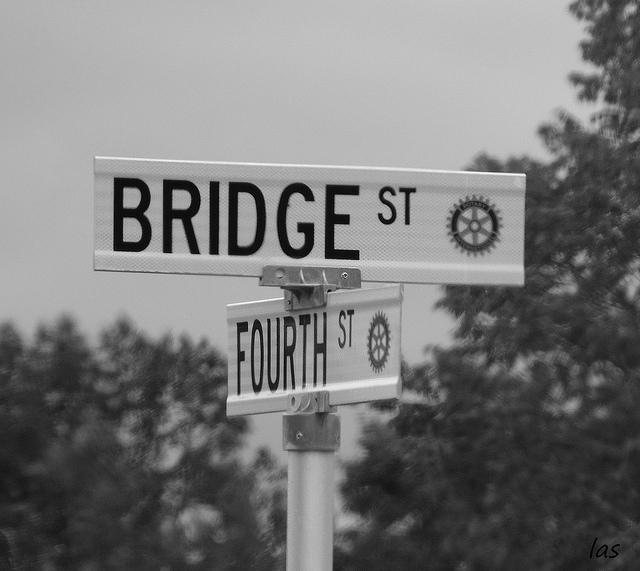What is the name of the two cross streets?
Short answer required. Bridge and fourth. What is the symbol on the street signs?
Answer briefly. Gear. Is this English?
Keep it brief. Yes. Could you see a movie here?
Answer briefly. No. What color is the sign?
Keep it brief. White. What does the sign say?
Be succinct. Bridge st. Is the street name the name of a famous person?
Be succinct. No. What is the color of the street's sign?
Be succinct. White. What intersection is this?
Concise answer only. Bridge & fourth. What road is this?
Be succinct. Bridge st. Is it a sunny day?
Answer briefly. No. What color is the sky?
Answer briefly. Gray. How many ways can you go here?
Keep it brief. 2. Is this a stop light?
Write a very short answer. No. What is the name of the street?
Concise answer only. Bridge. What kind of street sign in pictured?
Concise answer only. White. Is the sign for a street or Avenue?
Be succinct. Street. What do the first three letters on the street sign spell?
Quick response, please. Bri. 